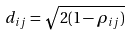Convert formula to latex. <formula><loc_0><loc_0><loc_500><loc_500>d _ { i j } = \sqrt { 2 ( 1 - \rho _ { i j } ) }</formula> 